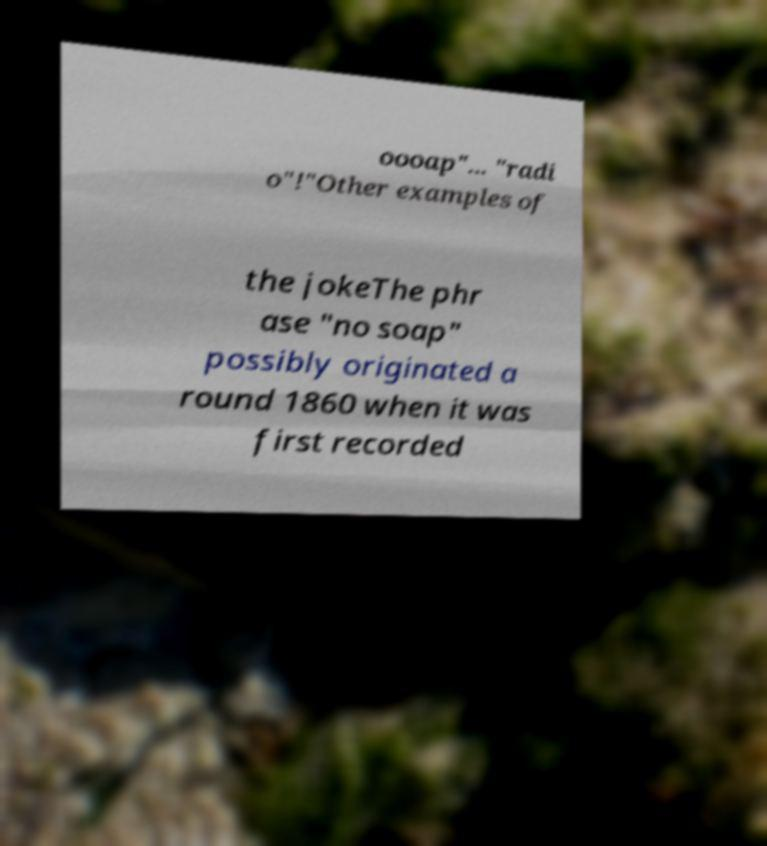Please identify and transcribe the text found in this image. oooap"... "radi o"!"Other examples of the jokeThe phr ase "no soap" possibly originated a round 1860 when it was first recorded 